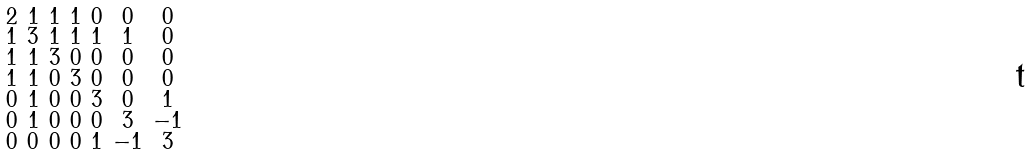<formula> <loc_0><loc_0><loc_500><loc_500>\begin{smallmatrix} 2 & 1 & 1 & 1 & 0 & 0 & 0 \\ 1 & 3 & 1 & 1 & 1 & 1 & 0 \\ 1 & 1 & 3 & 0 & 0 & 0 & 0 \\ 1 & 1 & 0 & 3 & 0 & 0 & 0 \\ 0 & 1 & 0 & 0 & 3 & 0 & 1 \\ 0 & 1 & 0 & 0 & 0 & 3 & - 1 \\ 0 & 0 & 0 & 0 & 1 & - 1 & 3 \end{smallmatrix}</formula> 